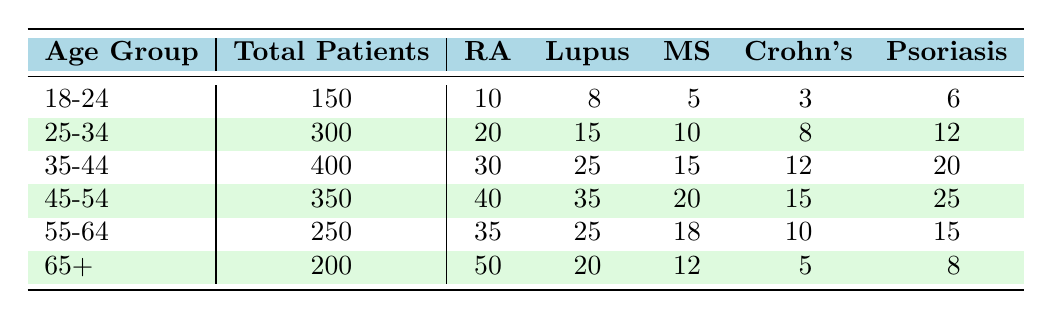What is the total number of patients in the 45-54 age group? In the table, I can directly look at the row for the 45-54 age group, where the Total Patients column indicates that there are 350 patients.
Answer: 350 Which autoimmune disease has the highest prevalence among patients aged 65 and older? By examining the row for the 65+ age group, I can see that Rheumatoid Arthritis has the highest number of cases at 50, compared to the other diseases listed in the same row.
Answer: Rheumatoid Arthritis What is the combined total of patients with Crohn's Disease across all age groups? I need to add the number of Crohn's Disease patients in each age group: 3 (18-24) + 8 (25-34) + 12 (35-44) + 15 (45-54) + 10 (55-64) + 5 (65+) = 53.
Answer: 53 Is there a higher prevalence of Lupus in the 35-44 age group compared to the 55-64 age group? Checking the cases for Lupus, I see 25 in the 35-44 age group and 25 in the 55-64 age group. Since both numbers are equal, I conclude it's not higher.
Answer: No What is the average number of patients with Multiple Sclerosis (MS) across all age groups? I will sum the number of MS patients: 5 (18-24) + 10 (25-34) + 15 (35-44) + 20 (45-54) + 18 (55-64) + 12 (65+) = 90. There are 6 age groups, so the average is 90/6 = 15.
Answer: 15 In which age group does the prevalence of Psoriasis significantly increase compared to the previous age group? Looking at the Psoriasis numbers, I see that it increases from 20 (35-44) to 25 (45-54). Thus, the significant increase occurs in the 45-54 age group.
Answer: 45-54 How many more patients have Rheumatoid Arthritis in the 55-64 age group compared to the 25-34 age group? Comparing Rheumatoid Arthritis cases, I find 35 in the 55-64 age group and 20 in the 25-34 age group. The difference is 35 - 20 = 15 more patients in the 55-64 age group.
Answer: 15 What percentage of patients aged 18-24 have Lupus? For patients aged 18-24, there are 8 cases of Lupus and a total of 150 patients. The percentage is calculated as (8/150)*100 = 5.33%.
Answer: 5.33% 